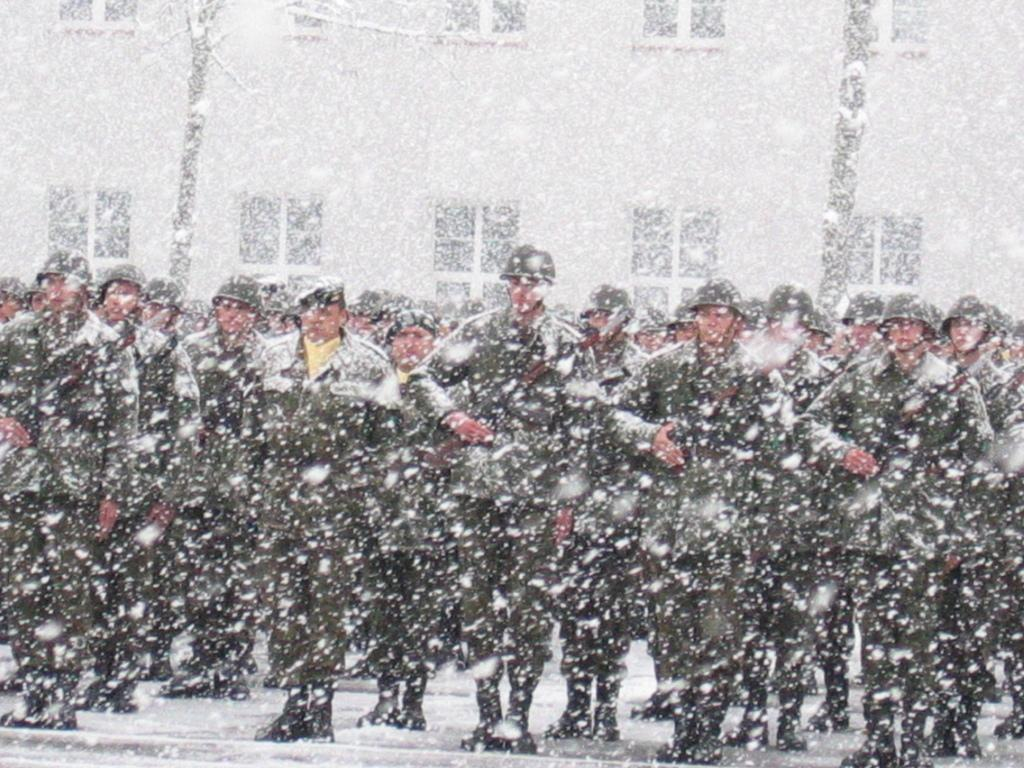How many people are in the image? There are many persons in the image. What are the persons wearing on their heads? The persons are wearing helmets. Where are the persons standing in the image? The persons are standing on the road. What is happening in the background of the image? There is a building in the background of the image. What is the weather condition in the image? There is snowfall in the image. What type of clouds can be seen in the image? There are no clouds visible in the image; it is snowing instead. What product are the persons in the image producing? The image does not show any production activity; the persons are simply standing on the road wearing helmets. 